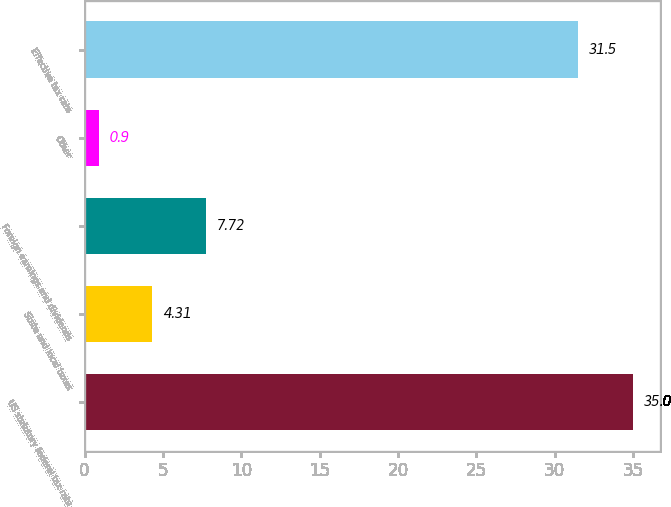Convert chart to OTSL. <chart><loc_0><loc_0><loc_500><loc_500><bar_chart><fcel>US statutory federal tax rate<fcel>State and local taxes<fcel>Foreign earnings and dividends<fcel>Other<fcel>Effective tax rate<nl><fcel>35<fcel>4.31<fcel>7.72<fcel>0.9<fcel>31.5<nl></chart> 